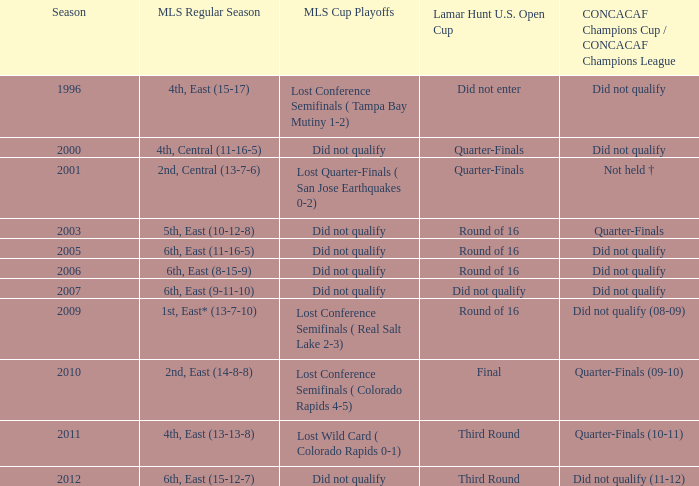How many mls cup playoffs where there for the mls regular season is 1st, east* (13-7-10)? 1.0. 